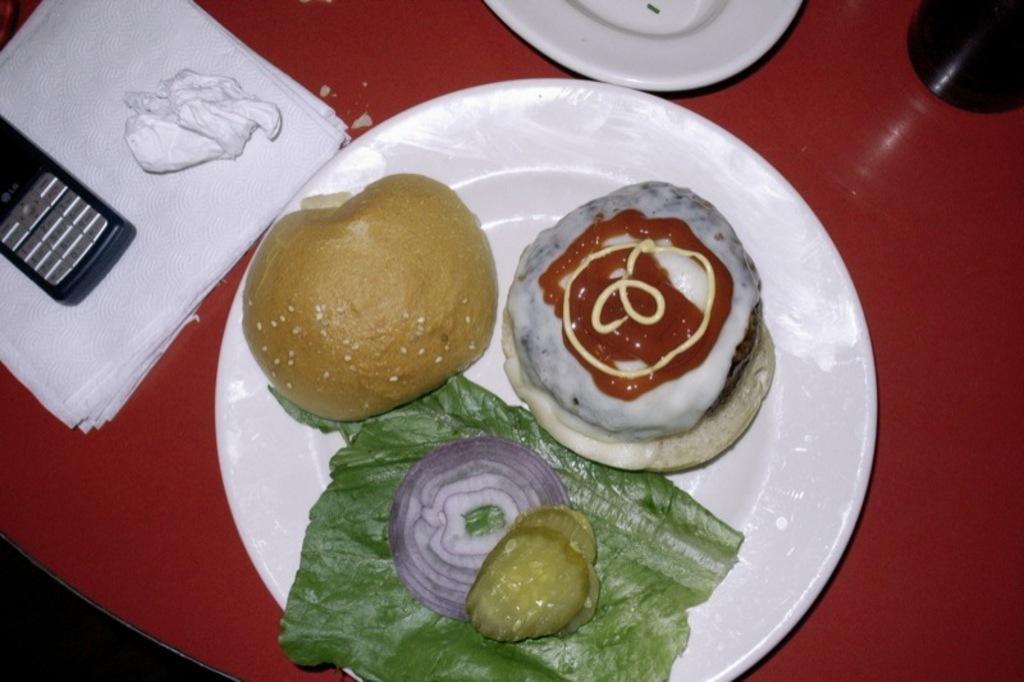What type of furniture is in the image? There is a table in the image. What is on top of the table? There is a mobile on the table. What can be used for cleaning or wiping on the table? Tissue papers are present on the table. What else is on the table besides the mobile and tissue papers? There are plates and food on the table. What type of cheese is present on the table in the image? There is no cheese present on the table in the image. 